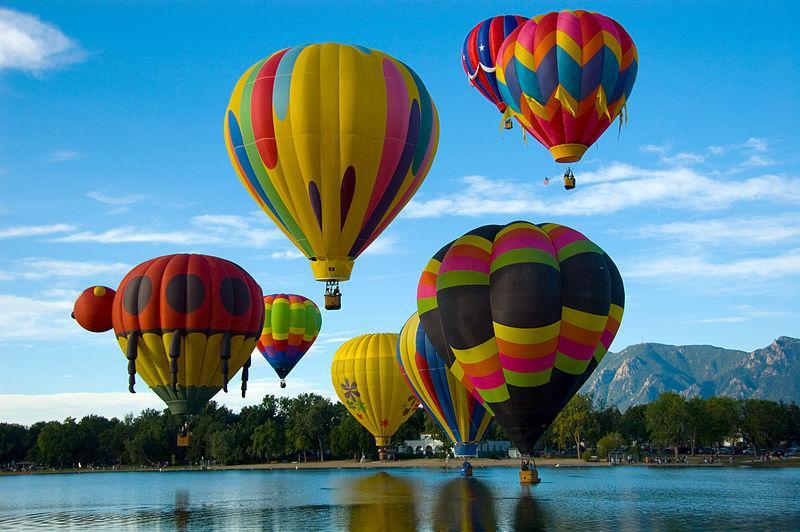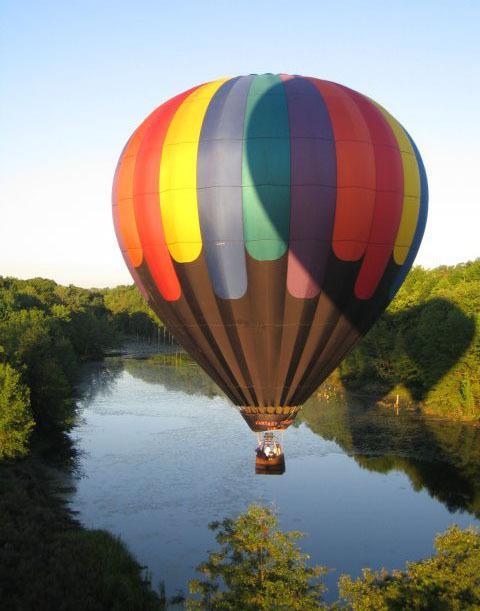The first image is the image on the left, the second image is the image on the right. Evaluate the accuracy of this statement regarding the images: "In one image, the balloon in the foreground has a face.". Is it true? Answer yes or no. No. The first image is the image on the left, the second image is the image on the right. Examine the images to the left and right. Is the description "In one image, a face is designed on the side of a large yellow hot-air balloon." accurate? Answer yes or no. No. 